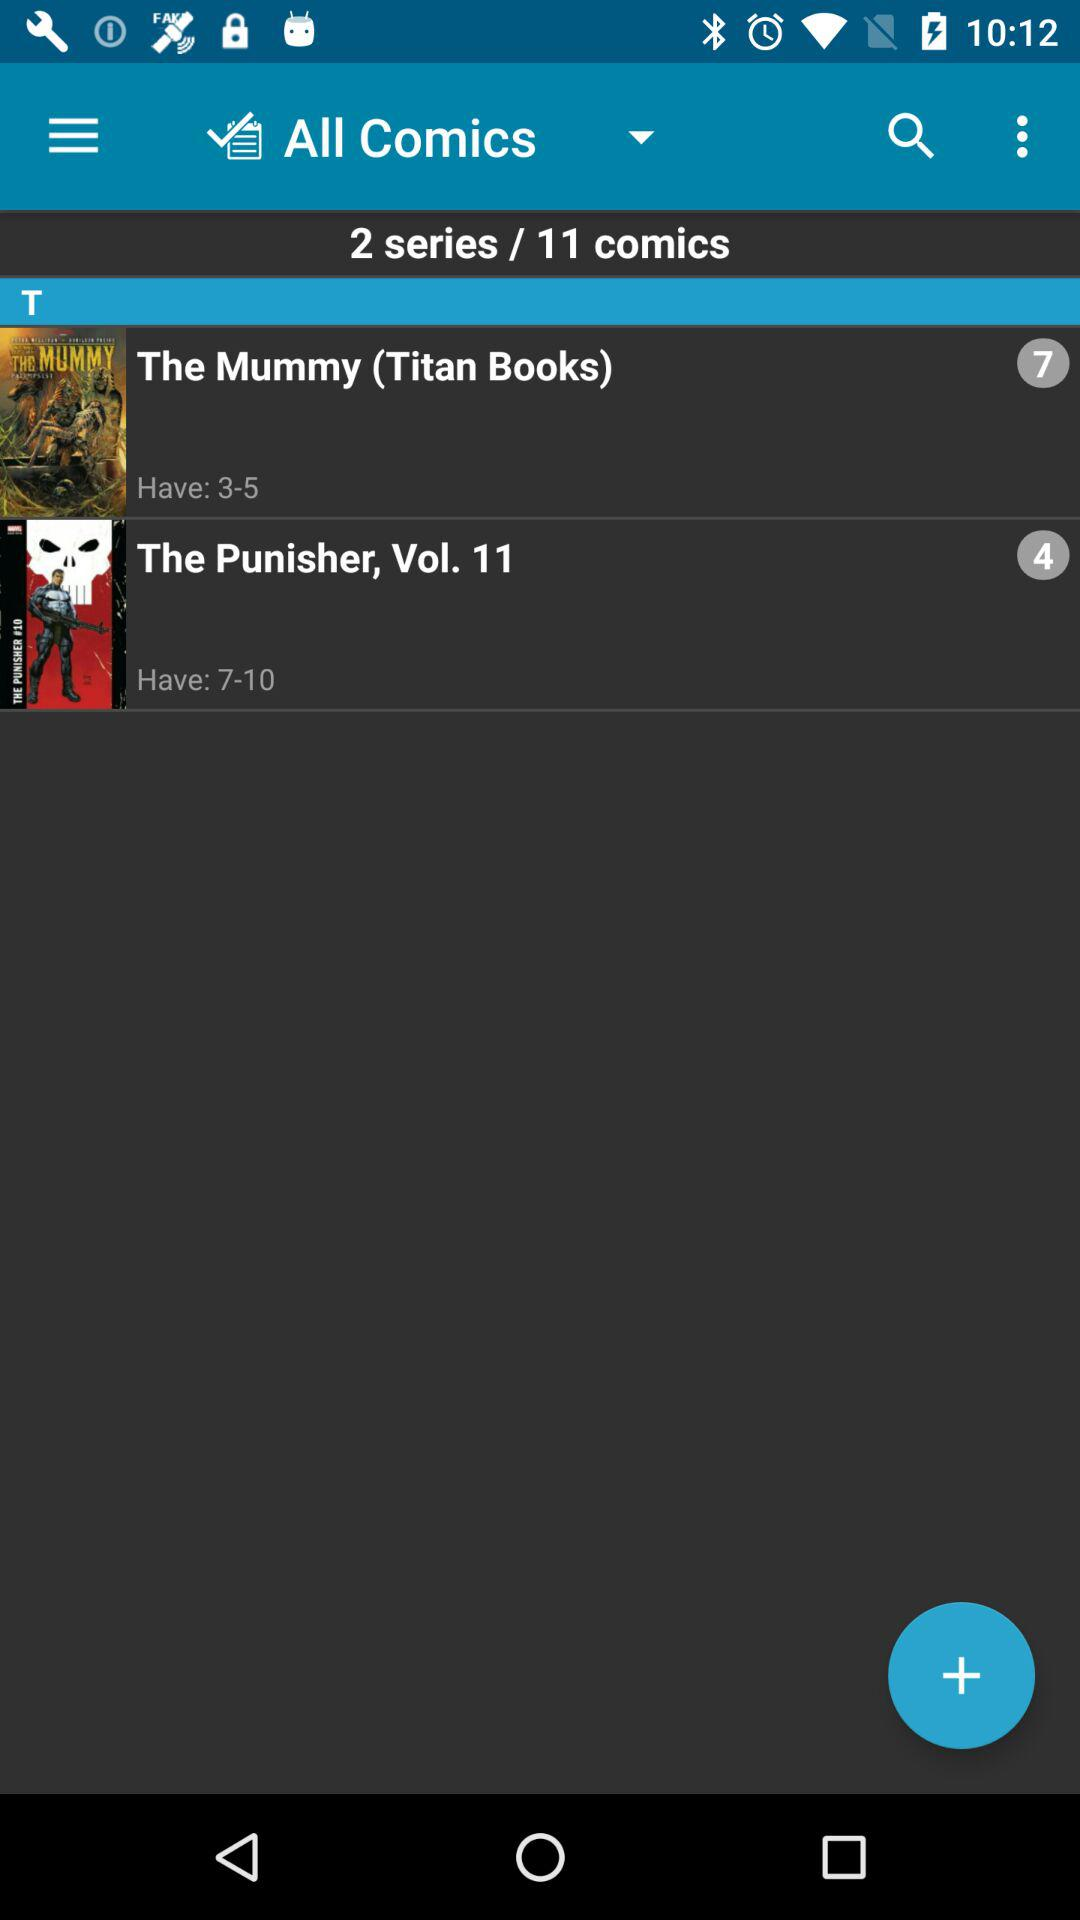What is the number of comics? The number of comics is 11. 